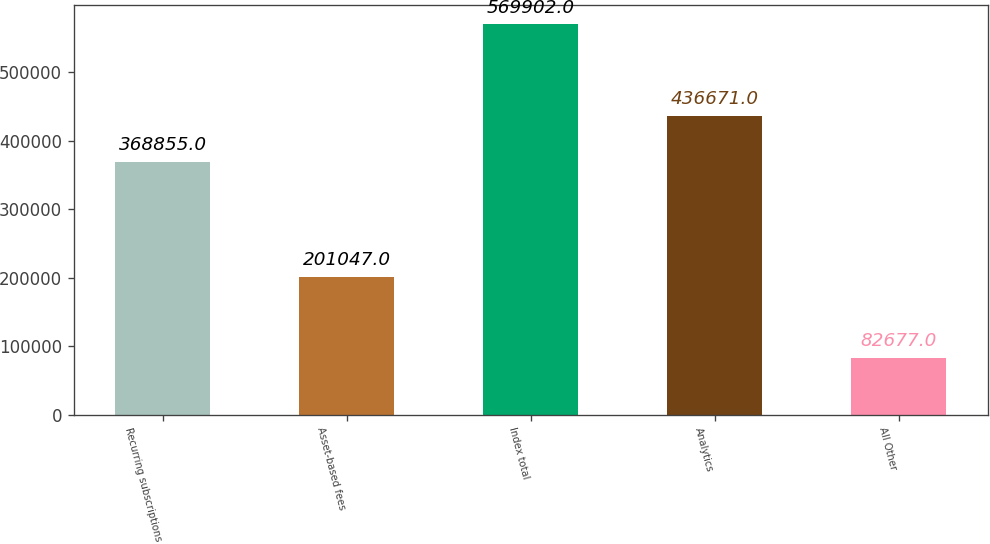Convert chart. <chart><loc_0><loc_0><loc_500><loc_500><bar_chart><fcel>Recurring subscriptions<fcel>Asset-based fees<fcel>Index total<fcel>Analytics<fcel>All Other<nl><fcel>368855<fcel>201047<fcel>569902<fcel>436671<fcel>82677<nl></chart> 